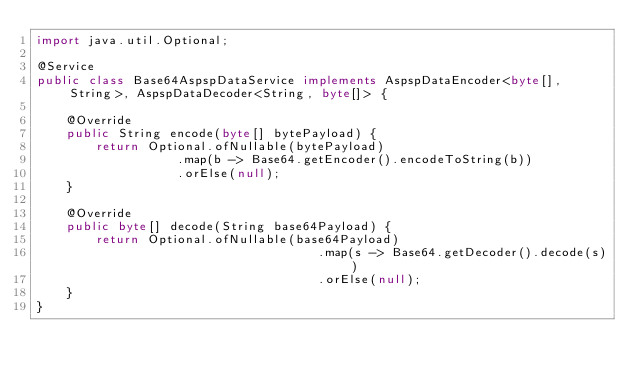<code> <loc_0><loc_0><loc_500><loc_500><_Java_>import java.util.Optional;

@Service
public class Base64AspspDataService implements AspspDataEncoder<byte[], String>, AspspDataDecoder<String, byte[]> {

    @Override
    public String encode(byte[] bytePayload) {
        return Optional.ofNullable(bytePayload)
                   .map(b -> Base64.getEncoder().encodeToString(b))
                   .orElse(null);
    }

    @Override
    public byte[] decode(String base64Payload) {
        return Optional.ofNullable(base64Payload)
                                      .map(s -> Base64.getDecoder().decode(s))
                                      .orElse(null);
    }
}
</code> 